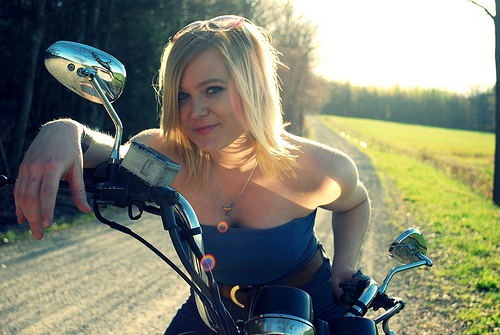<image>
Can you confirm if the head is next to the body? No. The head is not positioned next to the body. They are located in different areas of the scene. 